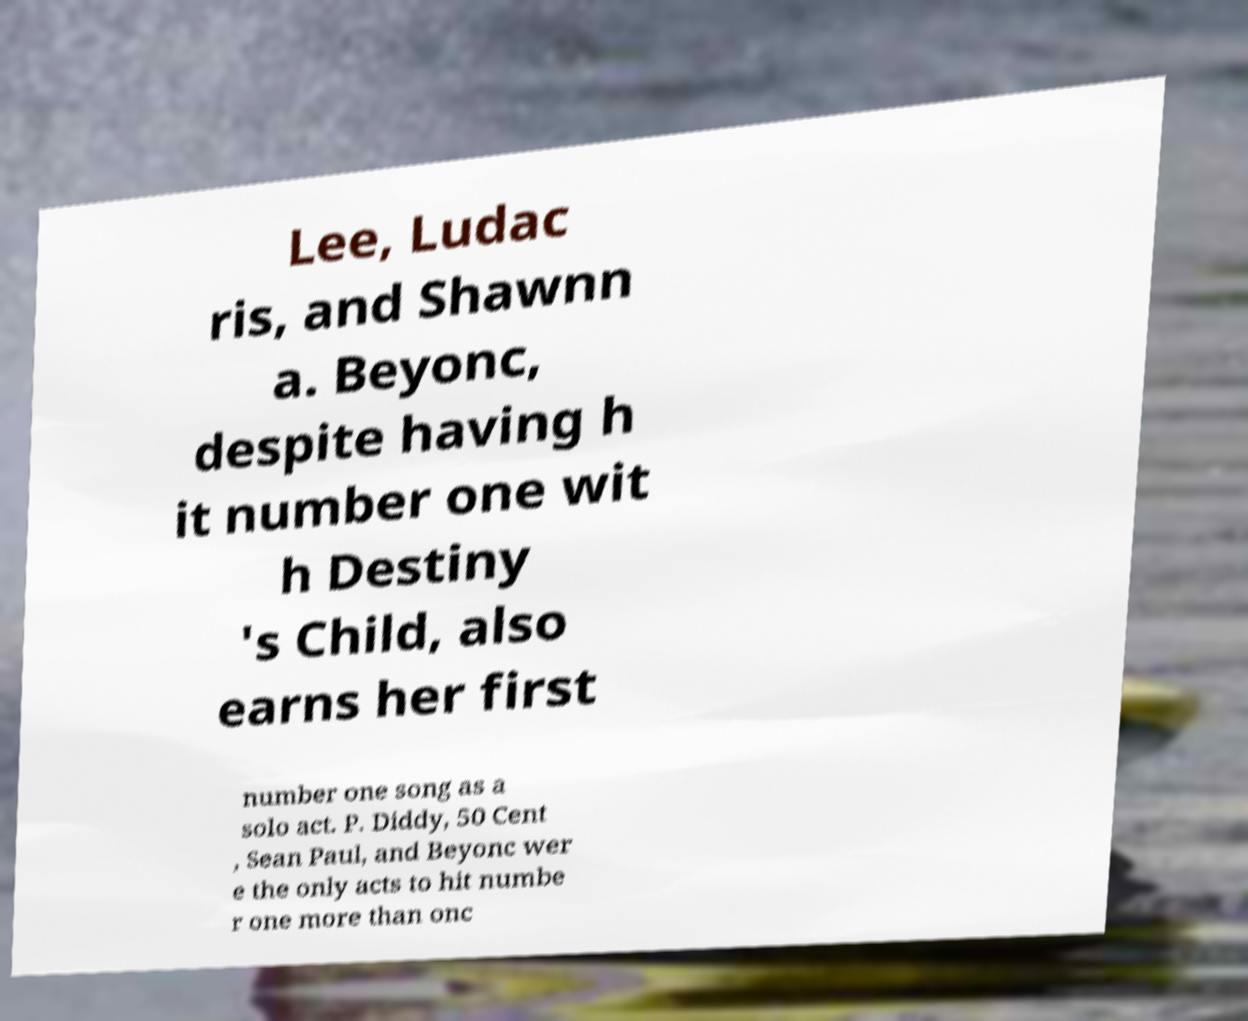Can you read and provide the text displayed in the image?This photo seems to have some interesting text. Can you extract and type it out for me? Lee, Ludac ris, and Shawnn a. Beyonc, despite having h it number one wit h Destiny 's Child, also earns her first number one song as a solo act. P. Diddy, 50 Cent , Sean Paul, and Beyonc wer e the only acts to hit numbe r one more than onc 